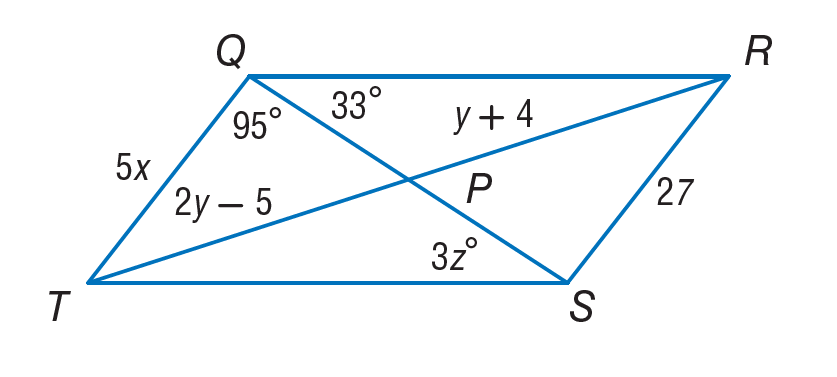Answer the mathemtical geometry problem and directly provide the correct option letter.
Question: If Q R S T is a parallelogram, find y.
Choices: A: 5.4 B: 9 C: 11 D: 22 B 